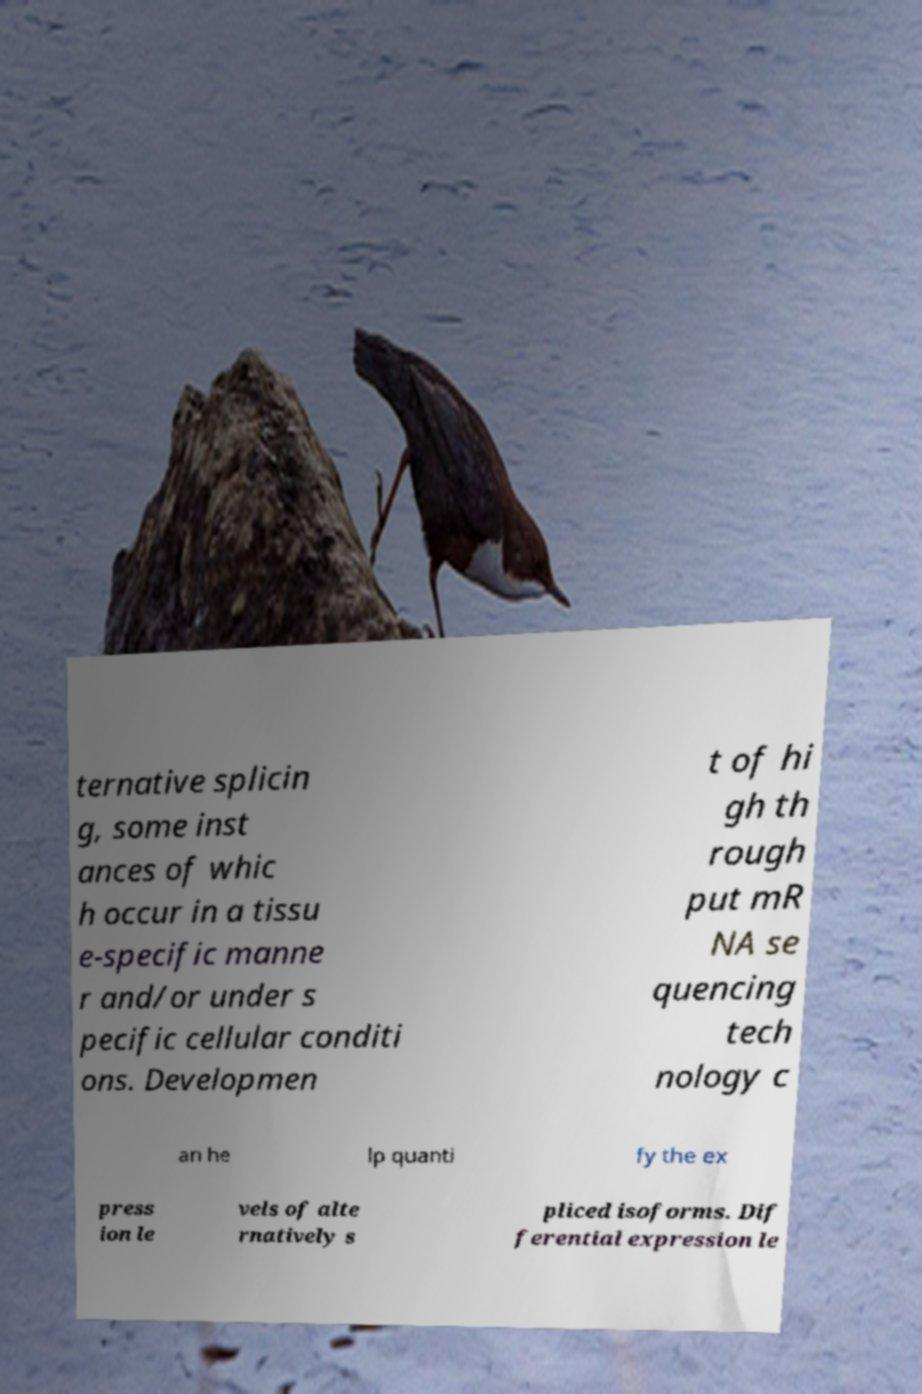Please read and relay the text visible in this image. What does it say? ternative splicin g, some inst ances of whic h occur in a tissu e-specific manne r and/or under s pecific cellular conditi ons. Developmen t of hi gh th rough put mR NA se quencing tech nology c an he lp quanti fy the ex press ion le vels of alte rnatively s pliced isoforms. Dif ferential expression le 